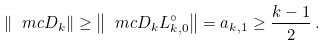Convert formula to latex. <formula><loc_0><loc_0><loc_500><loc_500>\| \ m c D _ { k } \| \geq \left \| \ m c D _ { k } L _ { k , 0 } ^ { \circ } \right \| = a _ { k , 1 } \geq \frac { k - 1 } { 2 } \, .</formula> 